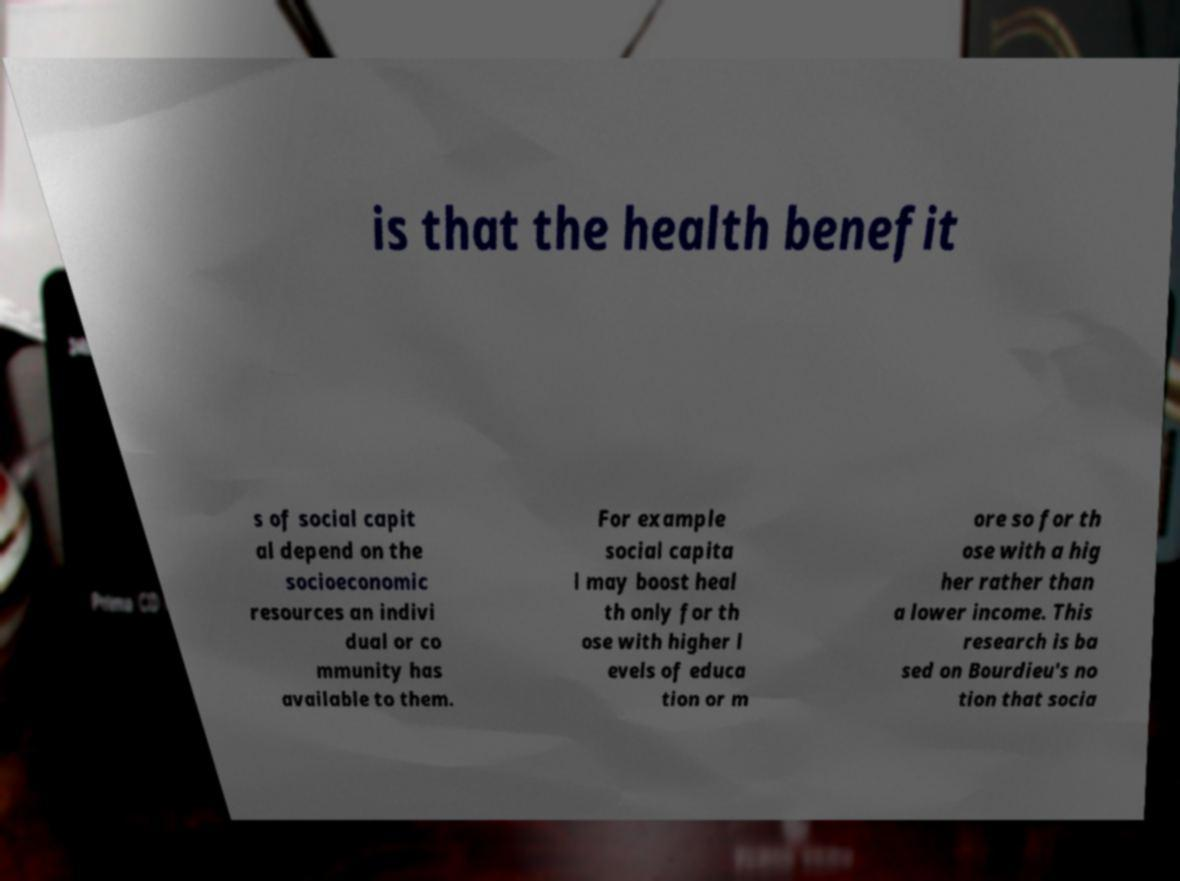Can you read and provide the text displayed in the image?This photo seems to have some interesting text. Can you extract and type it out for me? is that the health benefit s of social capit al depend on the socioeconomic resources an indivi dual or co mmunity has available to them. For example social capita l may boost heal th only for th ose with higher l evels of educa tion or m ore so for th ose with a hig her rather than a lower income. This research is ba sed on Bourdieu's no tion that socia 